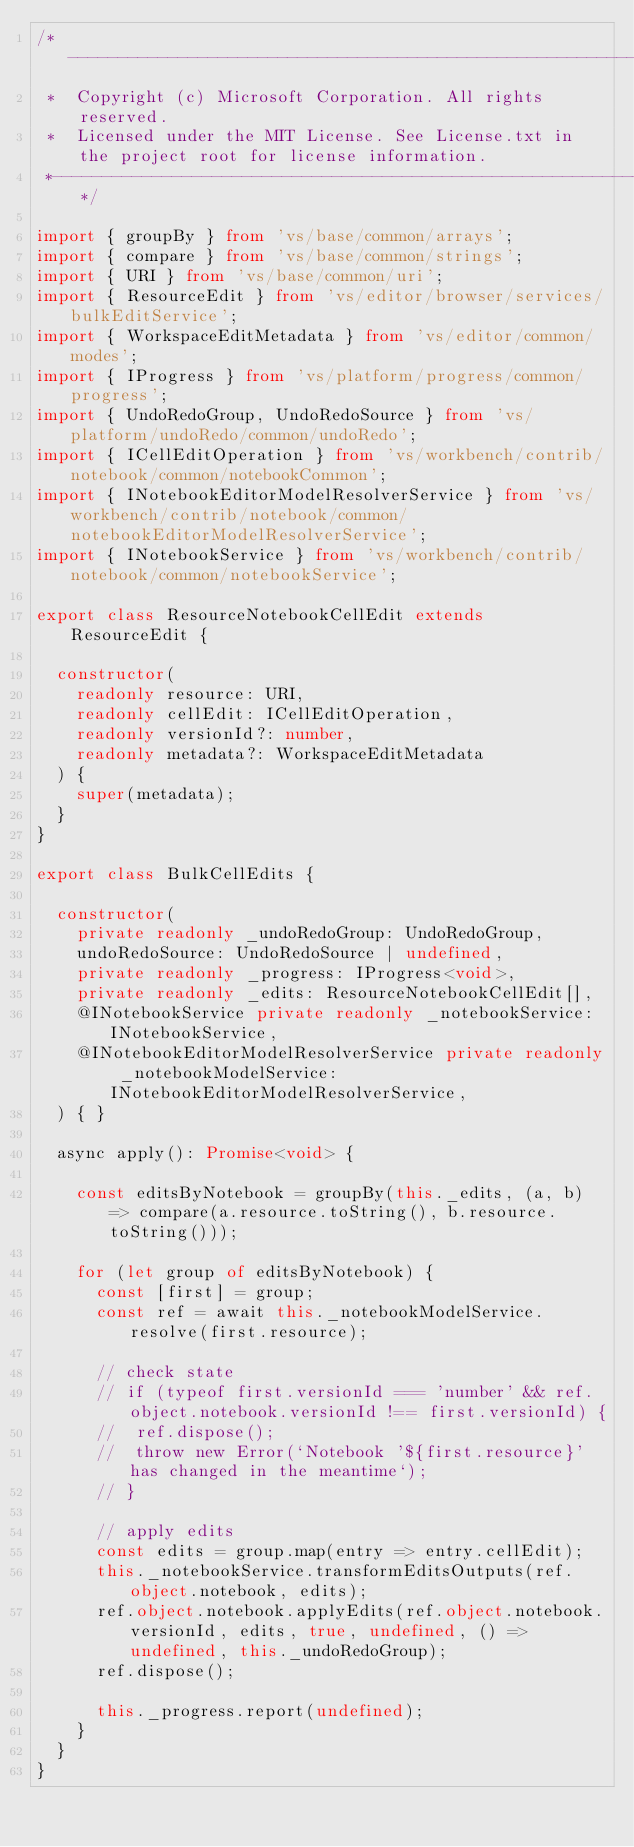Convert code to text. <code><loc_0><loc_0><loc_500><loc_500><_TypeScript_>/*---------------------------------------------------------------------------------------------
 *  Copyright (c) Microsoft Corporation. All rights reserved.
 *  Licensed under the MIT License. See License.txt in the project root for license information.
 *--------------------------------------------------------------------------------------------*/

import { groupBy } from 'vs/base/common/arrays';
import { compare } from 'vs/base/common/strings';
import { URI } from 'vs/base/common/uri';
import { ResourceEdit } from 'vs/editor/browser/services/bulkEditService';
import { WorkspaceEditMetadata } from 'vs/editor/common/modes';
import { IProgress } from 'vs/platform/progress/common/progress';
import { UndoRedoGroup, UndoRedoSource } from 'vs/platform/undoRedo/common/undoRedo';
import { ICellEditOperation } from 'vs/workbench/contrib/notebook/common/notebookCommon';
import { INotebookEditorModelResolverService } from 'vs/workbench/contrib/notebook/common/notebookEditorModelResolverService';
import { INotebookService } from 'vs/workbench/contrib/notebook/common/notebookService';

export class ResourceNotebookCellEdit extends ResourceEdit {

	constructor(
		readonly resource: URI,
		readonly cellEdit: ICellEditOperation,
		readonly versionId?: number,
		readonly metadata?: WorkspaceEditMetadata
	) {
		super(metadata);
	}
}

export class BulkCellEdits {

	constructor(
		private readonly _undoRedoGroup: UndoRedoGroup,
		undoRedoSource: UndoRedoSource | undefined,
		private readonly _progress: IProgress<void>,
		private readonly _edits: ResourceNotebookCellEdit[],
		@INotebookService private readonly _notebookService: INotebookService,
		@INotebookEditorModelResolverService private readonly _notebookModelService: INotebookEditorModelResolverService,
	) { }

	async apply(): Promise<void> {

		const editsByNotebook = groupBy(this._edits, (a, b) => compare(a.resource.toString(), b.resource.toString()));

		for (let group of editsByNotebook) {
			const [first] = group;
			const ref = await this._notebookModelService.resolve(first.resource);

			// check state
			// if (typeof first.versionId === 'number' && ref.object.notebook.versionId !== first.versionId) {
			// 	ref.dispose();
			// 	throw new Error(`Notebook '${first.resource}' has changed in the meantime`);
			// }

			// apply edits
			const edits = group.map(entry => entry.cellEdit);
			this._notebookService.transformEditsOutputs(ref.object.notebook, edits);
			ref.object.notebook.applyEdits(ref.object.notebook.versionId, edits, true, undefined, () => undefined, this._undoRedoGroup);
			ref.dispose();

			this._progress.report(undefined);
		}
	}
}
</code> 